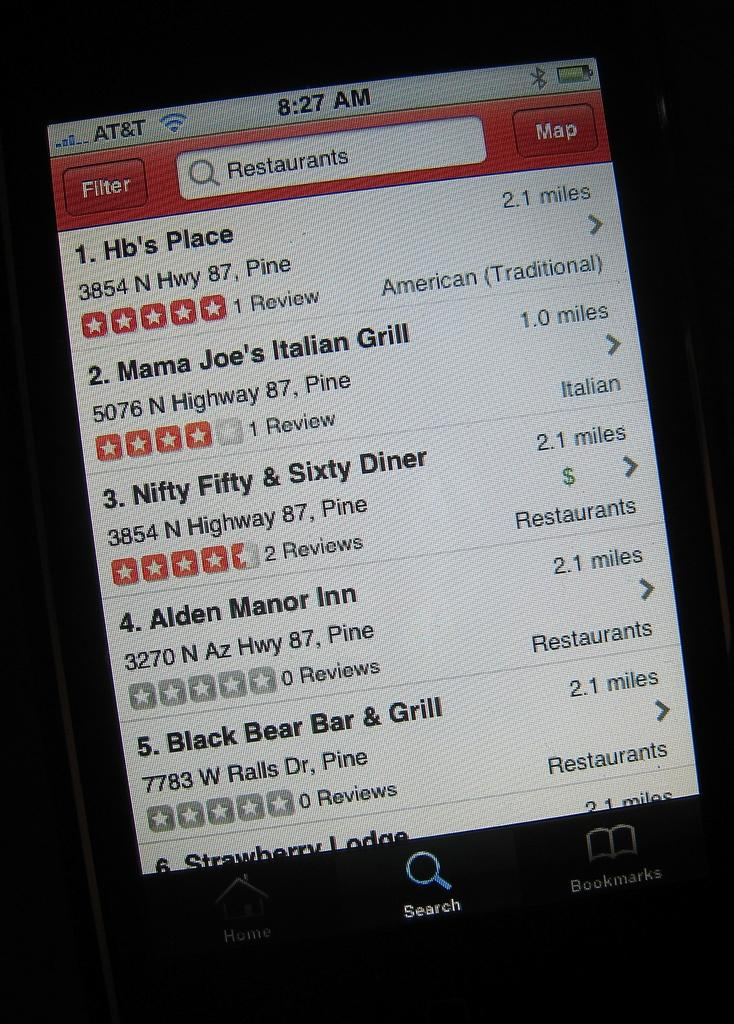<image>
Offer a succinct explanation of the picture presented. The time on the phone shown is 8:27 am. 